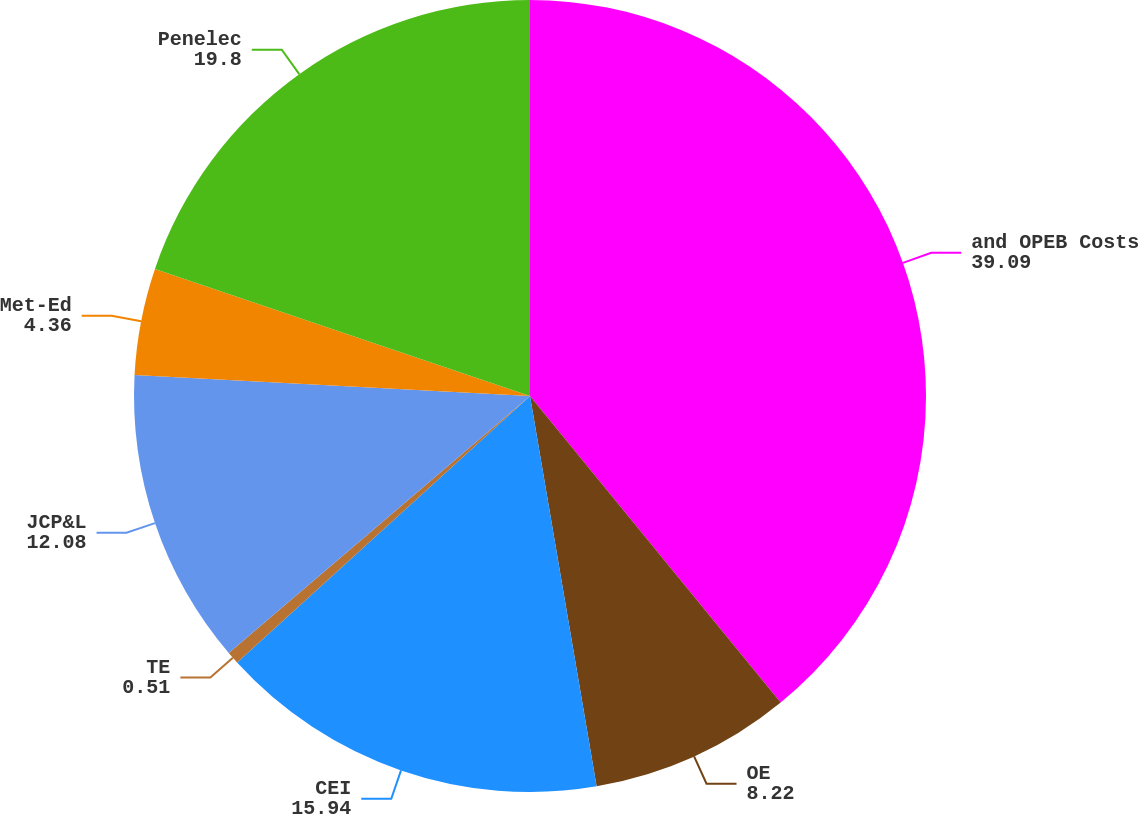Convert chart. <chart><loc_0><loc_0><loc_500><loc_500><pie_chart><fcel>and OPEB Costs<fcel>OE<fcel>CEI<fcel>TE<fcel>JCP&L<fcel>Met-Ed<fcel>Penelec<nl><fcel>39.09%<fcel>8.22%<fcel>15.94%<fcel>0.51%<fcel>12.08%<fcel>4.36%<fcel>19.8%<nl></chart> 